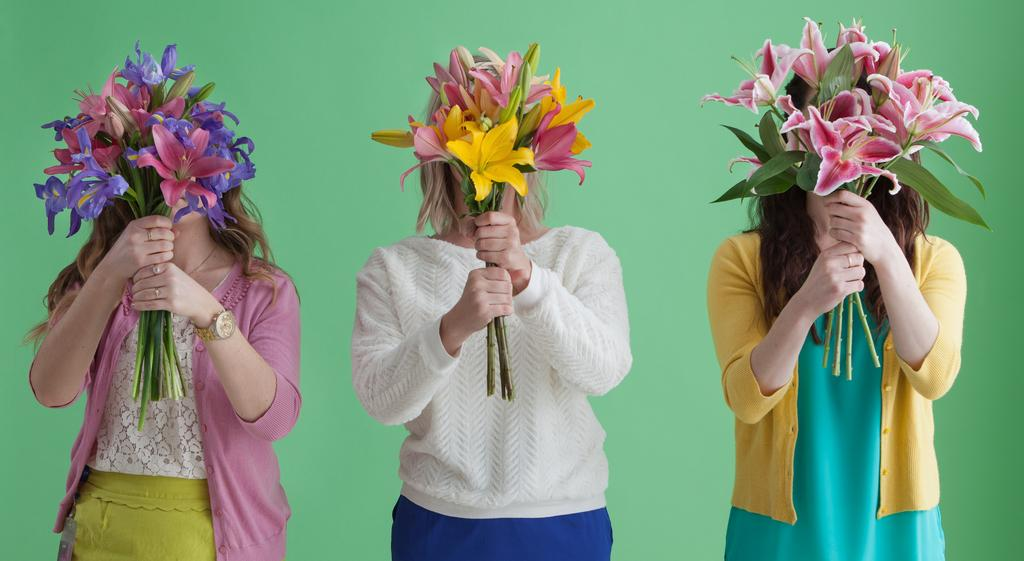How many people are in the image? There are three women in the image. What are the women doing in the image? The women are standing and covering their faces with flowers. What type of rabbit can be seen hopping in the yard in the image? There is no rabbit or yard present in the image; it features three women standing and covering their faces with flowers. 